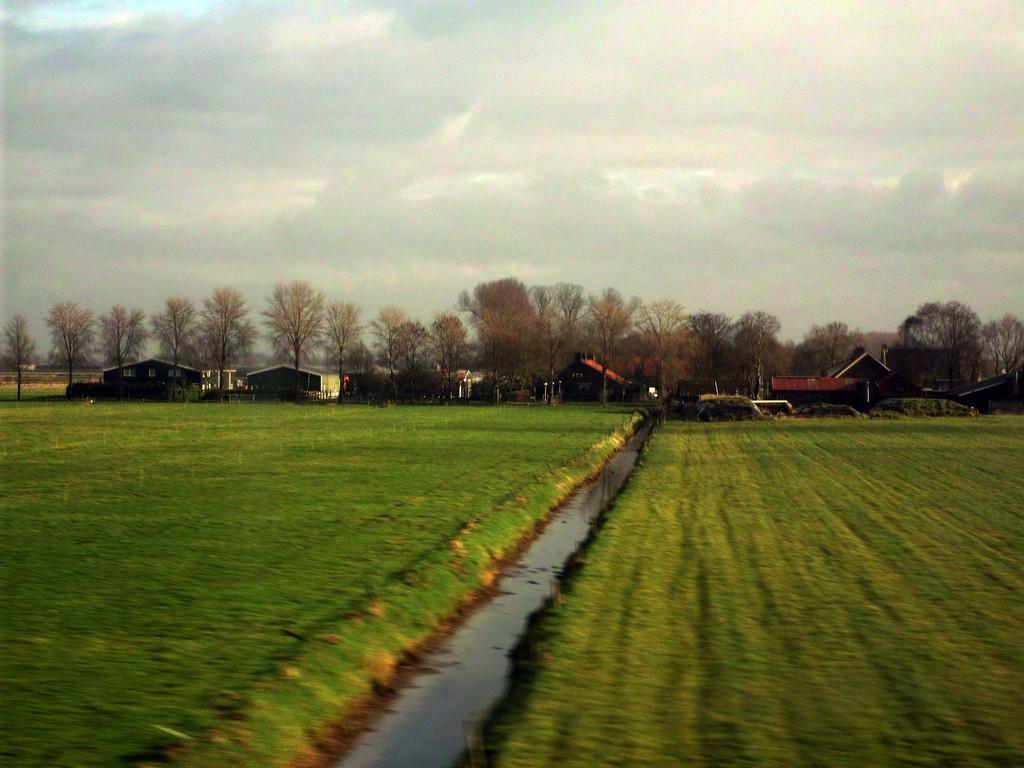In one or two sentences, can you explain what this image depicts? In the picture there may be fields, there is water, beside there are houses and there are trees, there is a clear sky. 